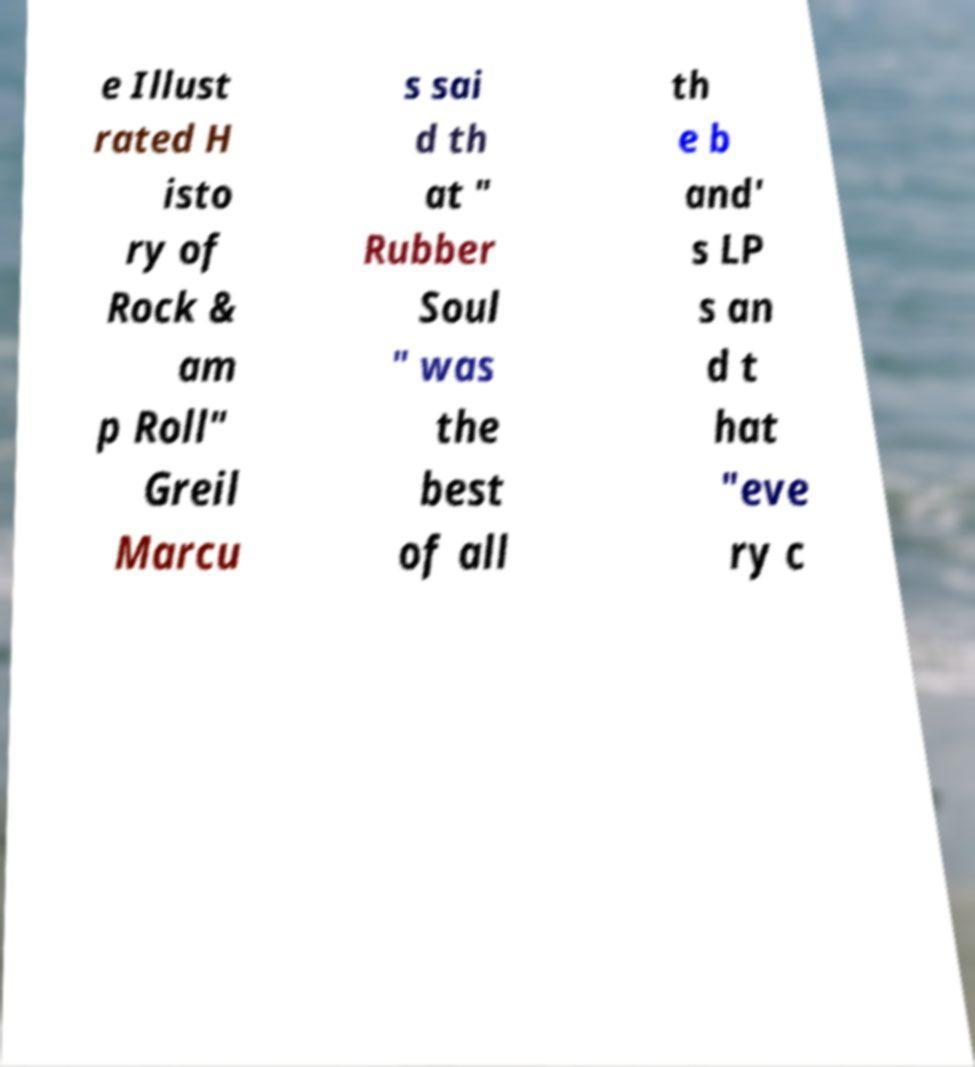What messages or text are displayed in this image? I need them in a readable, typed format. e Illust rated H isto ry of Rock & am p Roll" Greil Marcu s sai d th at " Rubber Soul " was the best of all th e b and' s LP s an d t hat "eve ry c 